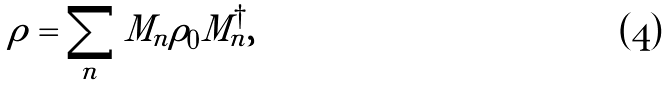Convert formula to latex. <formula><loc_0><loc_0><loc_500><loc_500>\rho = \sum _ { n } M _ { n } \rho _ { 0 } M _ { n } ^ { \dagger } ,</formula> 